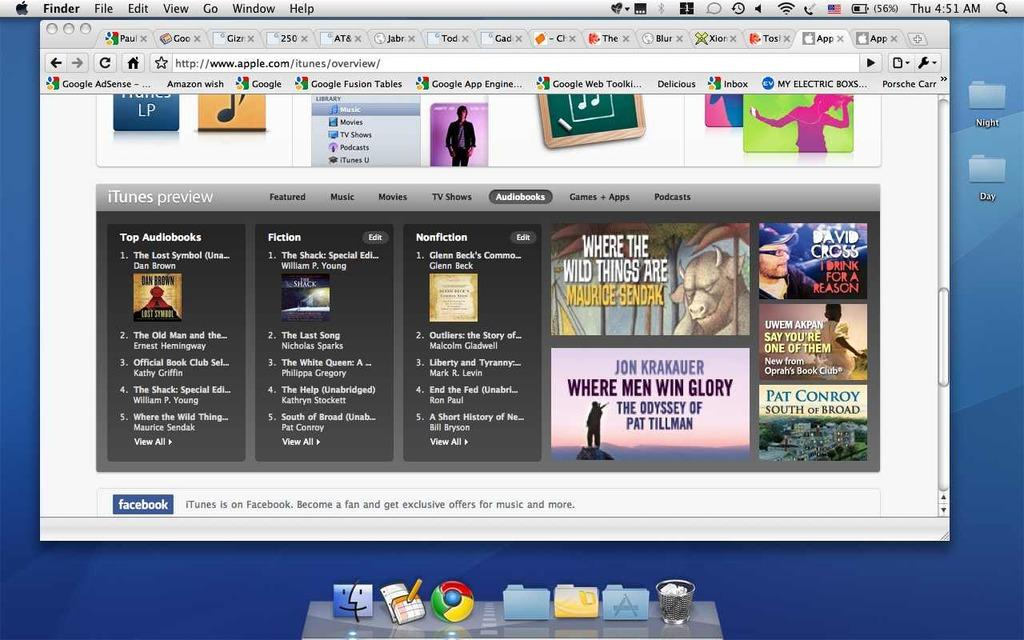Provide a one-sentence caption for the provided image. The website that is shown here is Apple. 